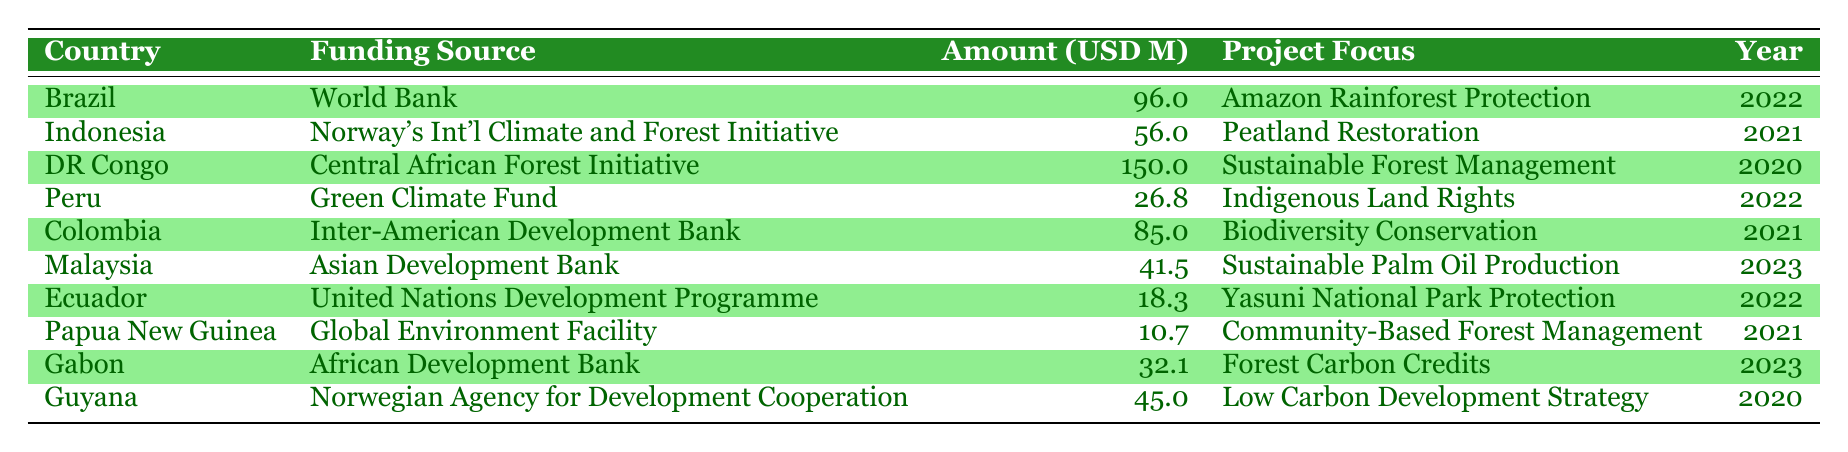What is the largest funding amount allocated among all countries? By scanning the "Amount (USD Millions)" column, we can identify the highest value, which is 150 million allocated to the Democratic Republic of Congo.
Answer: 150 Which country received funding for "Biodiversity Conservation"? Looking at the "Project Focus" column, we see that Colombia is associated with "Biodiversity Conservation".
Answer: Colombia What is the total amount of funding allocated to Peru and Ecuador combined? To find this, we need to sum the amounts allocated to Peru (26.8 million) and Ecuador (18.3 million). Therefore, 26.8 + 18.3 = 45.1 million.
Answer: 45.1 Did Guyana receive funding from the World Bank? Reviewing the "Funding Source" column, we see that Guyana's funding comes from the Norwegian Agency for Development Cooperation, not the World Bank.
Answer: No Which funding sources are attributed to projects in 2022? We examine the "Year" column for 2022 and find the projects from Brazil, Peru, and Ecuador, which correspond to the World Bank, Green Climate Fund, and United Nations Development Programme, respectively.
Answer: World Bank, Green Climate Fund, United Nations Development Programme What percentage of the total funding in the table is allocated to the Democratic Republic of Congo? First, we calculate the total funding by summing all amounts: 96 + 56 + 150 + 26.8 + 85 + 41.5 + 18.3 + 10.7 + 32.1 + 45 =  541.4 million. Next, we find the percentage allocated to the Democratic Republic of Congo: (150 / 541.4) * 100 ≈ 27.7%.
Answer: 27.7 How many projects focus on community management or rights related to land? We review the table and find that the projects focusing on community aspects are "Indigenous Land Rights" in Peru, and "Community-Based Forest Management" in Papua New Guinea, totaling two projects.
Answer: 2 Is the funding amount for Malaysia higher or lower than that for Indonesia? The funding amount for Malaysia is 41.5 million, while for Indonesia it is 56 million. Comparing these, 41.5 is lower than 56.
Answer: Lower Which country's project was focused on "Sustainable Palm Oil Production"? Checking the "Project Focus" column, we see that Malaysia has the project focused on "Sustainable Palm Oil Production".
Answer: Malaysia 